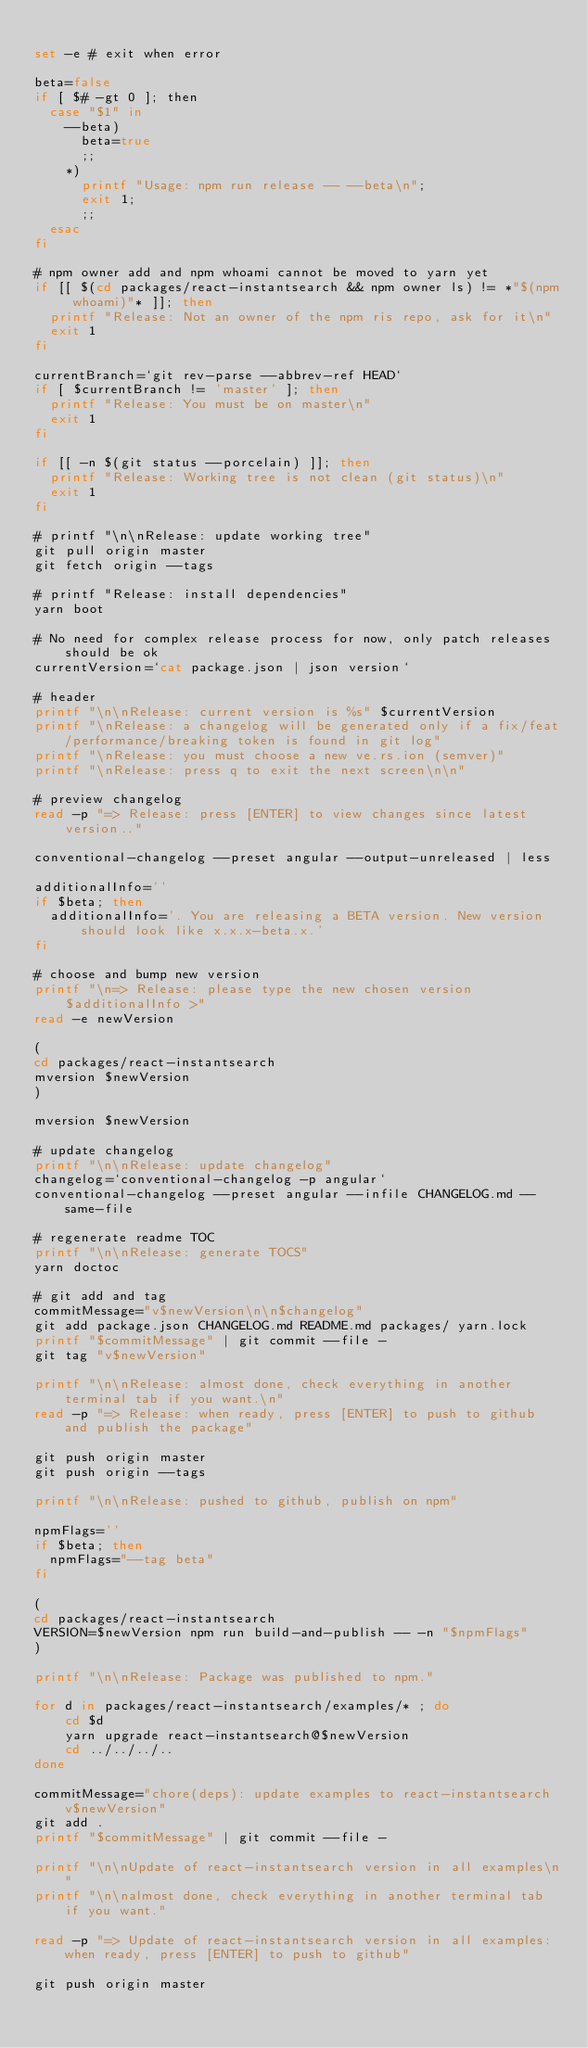<code> <loc_0><loc_0><loc_500><loc_500><_Bash_>
set -e # exit when error

beta=false
if [ $# -gt 0 ]; then
  case "$1" in
    --beta)
      beta=true
      ;;
    *)
      printf "Usage: npm run release -- --beta\n";
      exit 1;
      ;;
  esac
fi

# npm owner add and npm whoami cannot be moved to yarn yet
if [[ $(cd packages/react-instantsearch && npm owner ls) != *"$(npm whoami)"* ]]; then
  printf "Release: Not an owner of the npm ris repo, ask for it\n"
  exit 1
fi

currentBranch=`git rev-parse --abbrev-ref HEAD`
if [ $currentBranch != 'master' ]; then
  printf "Release: You must be on master\n"
  exit 1
fi

if [[ -n $(git status --porcelain) ]]; then
  printf "Release: Working tree is not clean (git status)\n"
  exit 1
fi

# printf "\n\nRelease: update working tree"
git pull origin master
git fetch origin --tags

# printf "Release: install dependencies"
yarn boot

# No need for complex release process for now, only patch releases should be ok
currentVersion=`cat package.json | json version`

# header
printf "\n\nRelease: current version is %s" $currentVersion
printf "\nRelease: a changelog will be generated only if a fix/feat/performance/breaking token is found in git log"
printf "\nRelease: you must choose a new ve.rs.ion (semver)"
printf "\nRelease: press q to exit the next screen\n\n"

# preview changelog
read -p "=> Release: press [ENTER] to view changes since latest version.."

conventional-changelog --preset angular --output-unreleased | less

additionalInfo=''
if $beta; then
  additionalInfo='. You are releasing a BETA version. New version should look like x.x.x-beta.x.'
fi

# choose and bump new version
printf "\n=> Release: please type the new chosen version $additionalInfo >"
read -e newVersion

(
cd packages/react-instantsearch
mversion $newVersion
)

mversion $newVersion

# update changelog
printf "\n\nRelease: update changelog"
changelog=`conventional-changelog -p angular`
conventional-changelog --preset angular --infile CHANGELOG.md --same-file

# regenerate readme TOC
printf "\n\nRelease: generate TOCS"
yarn doctoc

# git add and tag
commitMessage="v$newVersion\n\n$changelog"
git add package.json CHANGELOG.md README.md packages/ yarn.lock
printf "$commitMessage" | git commit --file -
git tag "v$newVersion"

printf "\n\nRelease: almost done, check everything in another terminal tab if you want.\n"
read -p "=> Release: when ready, press [ENTER] to push to github and publish the package"

git push origin master
git push origin --tags

printf "\n\nRelease: pushed to github, publish on npm"

npmFlags=''
if $beta; then
  npmFlags="--tag beta"
fi

(
cd packages/react-instantsearch
VERSION=$newVersion npm run build-and-publish -- -n "$npmFlags"
)

printf "\n\nRelease: Package was published to npm."

for d in packages/react-instantsearch/examples/* ; do
    cd $d
    yarn upgrade react-instantsearch@$newVersion
    cd ../../../..
done

commitMessage="chore(deps): update examples to react-instantsearch v$newVersion"
git add .
printf "$commitMessage" | git commit --file -

printf "\n\nUpdate of react-instantsearch version in all examples\n"
printf "\n\nalmost done, check everything in another terminal tab if you want."

read -p "=> Update of react-instantsearch version in all examples: when ready, press [ENTER] to push to github"

git push origin master
</code> 